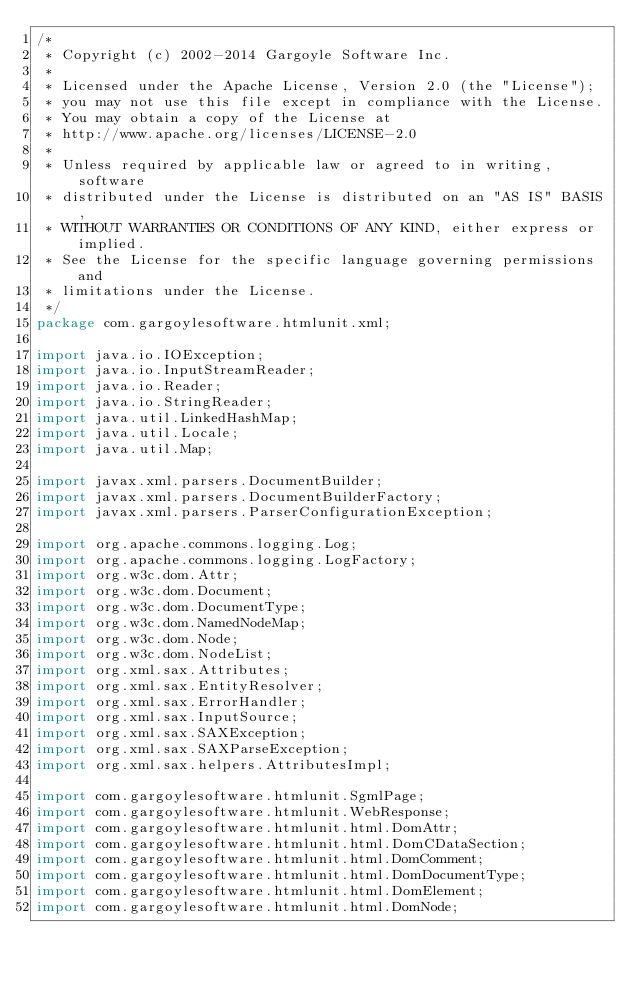Convert code to text. <code><loc_0><loc_0><loc_500><loc_500><_Java_>/*
 * Copyright (c) 2002-2014 Gargoyle Software Inc.
 *
 * Licensed under the Apache License, Version 2.0 (the "License");
 * you may not use this file except in compliance with the License.
 * You may obtain a copy of the License at
 * http://www.apache.org/licenses/LICENSE-2.0
 *
 * Unless required by applicable law or agreed to in writing, software
 * distributed under the License is distributed on an "AS IS" BASIS,
 * WITHOUT WARRANTIES OR CONDITIONS OF ANY KIND, either express or implied.
 * See the License for the specific language governing permissions and
 * limitations under the License.
 */
package com.gargoylesoftware.htmlunit.xml;

import java.io.IOException;
import java.io.InputStreamReader;
import java.io.Reader;
import java.io.StringReader;
import java.util.LinkedHashMap;
import java.util.Locale;
import java.util.Map;

import javax.xml.parsers.DocumentBuilder;
import javax.xml.parsers.DocumentBuilderFactory;
import javax.xml.parsers.ParserConfigurationException;

import org.apache.commons.logging.Log;
import org.apache.commons.logging.LogFactory;
import org.w3c.dom.Attr;
import org.w3c.dom.Document;
import org.w3c.dom.DocumentType;
import org.w3c.dom.NamedNodeMap;
import org.w3c.dom.Node;
import org.w3c.dom.NodeList;
import org.xml.sax.Attributes;
import org.xml.sax.EntityResolver;
import org.xml.sax.ErrorHandler;
import org.xml.sax.InputSource;
import org.xml.sax.SAXException;
import org.xml.sax.SAXParseException;
import org.xml.sax.helpers.AttributesImpl;

import com.gargoylesoftware.htmlunit.SgmlPage;
import com.gargoylesoftware.htmlunit.WebResponse;
import com.gargoylesoftware.htmlunit.html.DomAttr;
import com.gargoylesoftware.htmlunit.html.DomCDataSection;
import com.gargoylesoftware.htmlunit.html.DomComment;
import com.gargoylesoftware.htmlunit.html.DomDocumentType;
import com.gargoylesoftware.htmlunit.html.DomElement;
import com.gargoylesoftware.htmlunit.html.DomNode;</code> 